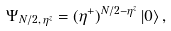<formula> <loc_0><loc_0><loc_500><loc_500>\Psi _ { N / 2 , \, \eta ^ { z } } = ( \eta ^ { + } ) ^ { N / 2 - \eta ^ { z } } \left | 0 \right \rangle ,</formula> 